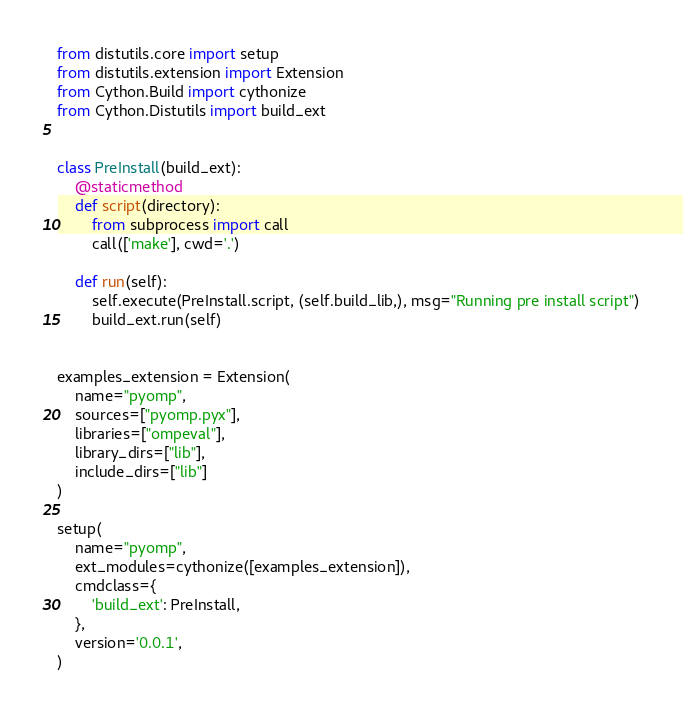Convert code to text. <code><loc_0><loc_0><loc_500><loc_500><_Python_>from distutils.core import setup
from distutils.extension import Extension
from Cython.Build import cythonize
from Cython.Distutils import build_ext


class PreInstall(build_ext):
    @staticmethod
    def script(directory):
        from subprocess import call
        call(['make'], cwd='.')

    def run(self):
        self.execute(PreInstall.script, (self.build_lib,), msg="Running pre install script")
        build_ext.run(self)


examples_extension = Extension(
    name="pyomp",
    sources=["pyomp.pyx"],
    libraries=["ompeval"],
    library_dirs=["lib"],
    include_dirs=["lib"]
)

setup(
    name="pyomp",
    ext_modules=cythonize([examples_extension]),
    cmdclass={
        'build_ext': PreInstall,    
    },
    version='0.0.1',
)

</code> 